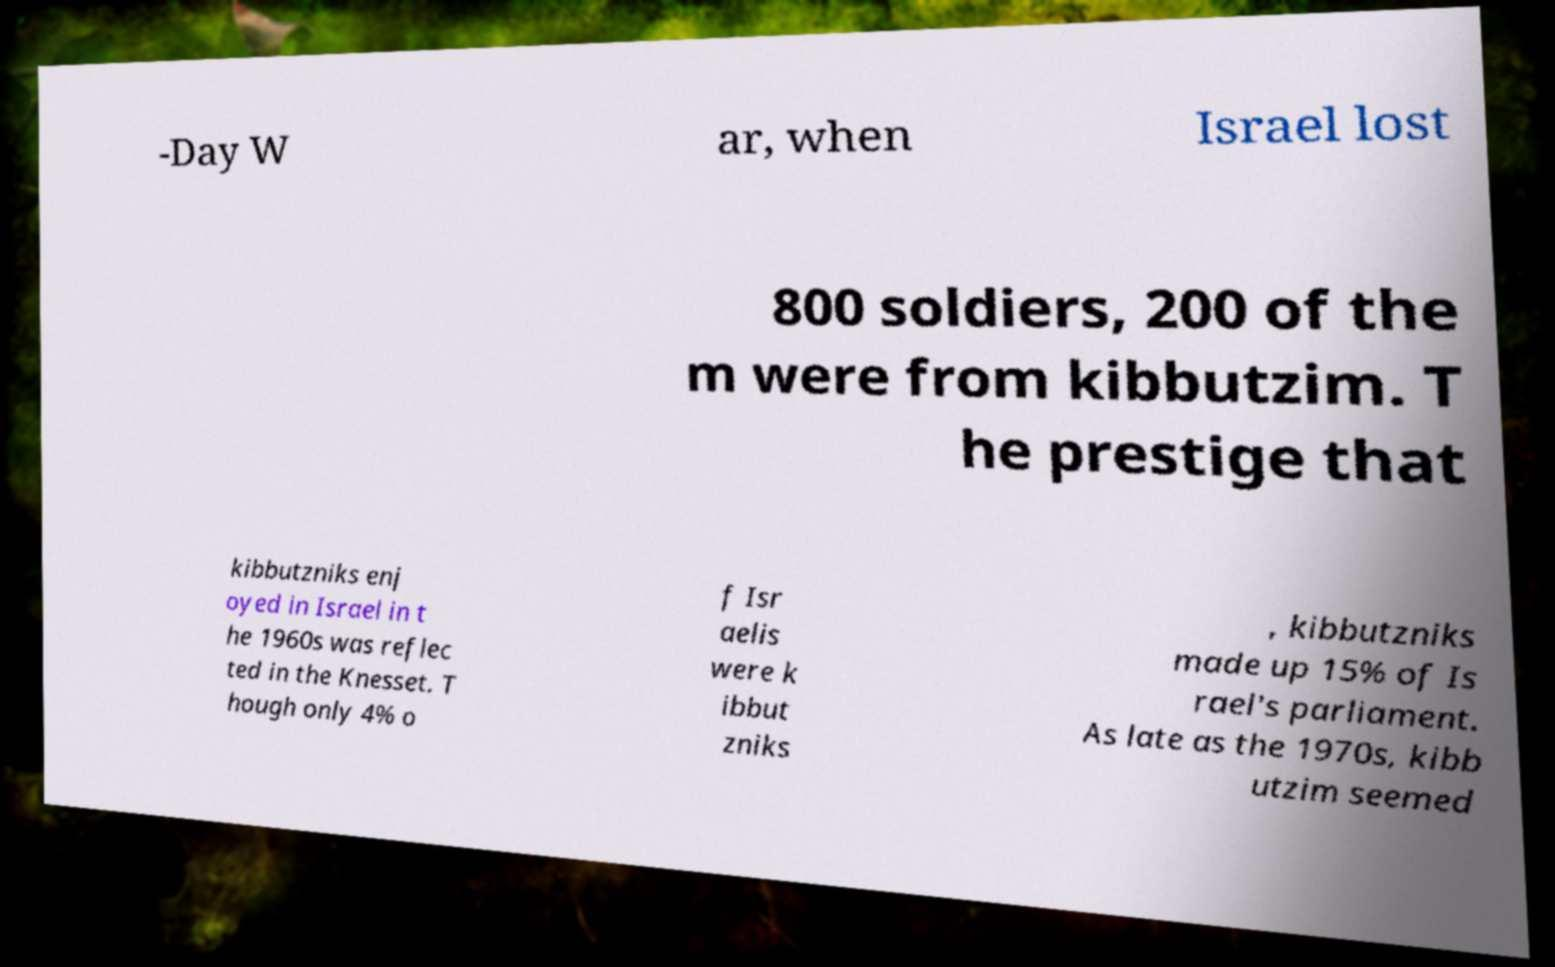Could you extract and type out the text from this image? -Day W ar, when Israel lost 800 soldiers, 200 of the m were from kibbutzim. T he prestige that kibbutzniks enj oyed in Israel in t he 1960s was reflec ted in the Knesset. T hough only 4% o f Isr aelis were k ibbut zniks , kibbutzniks made up 15% of Is rael's parliament. As late as the 1970s, kibb utzim seemed 